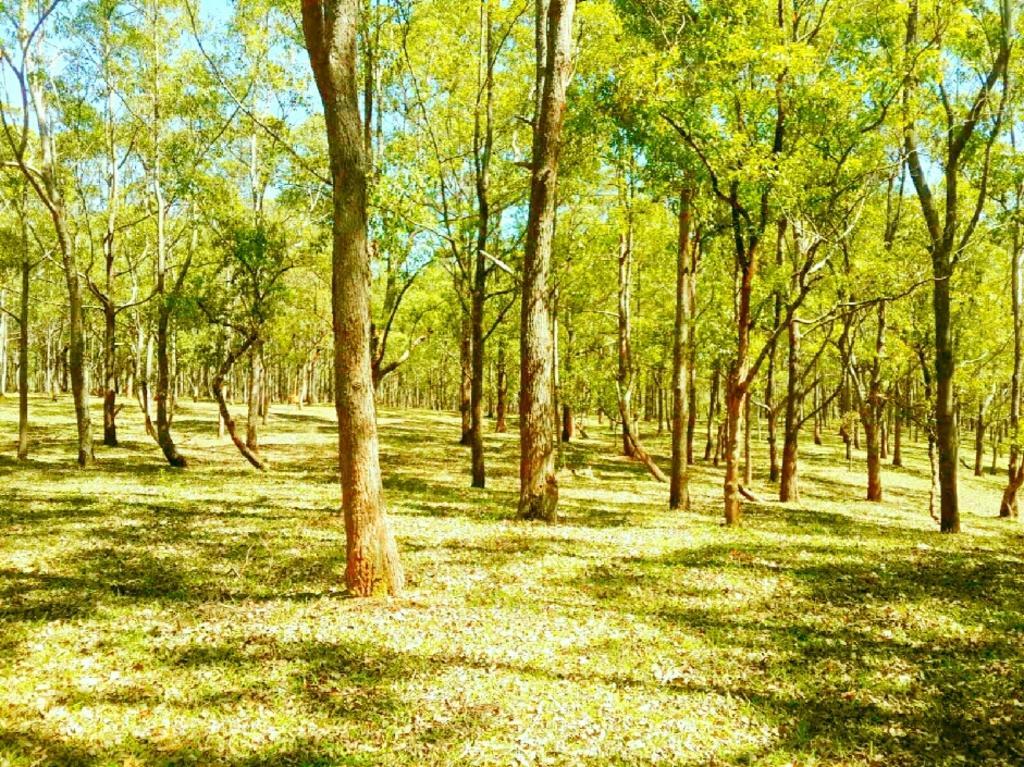Could you give a brief overview of what you see in this image? On the ground there is grass. Also there are many trees. In the background there is sky. 